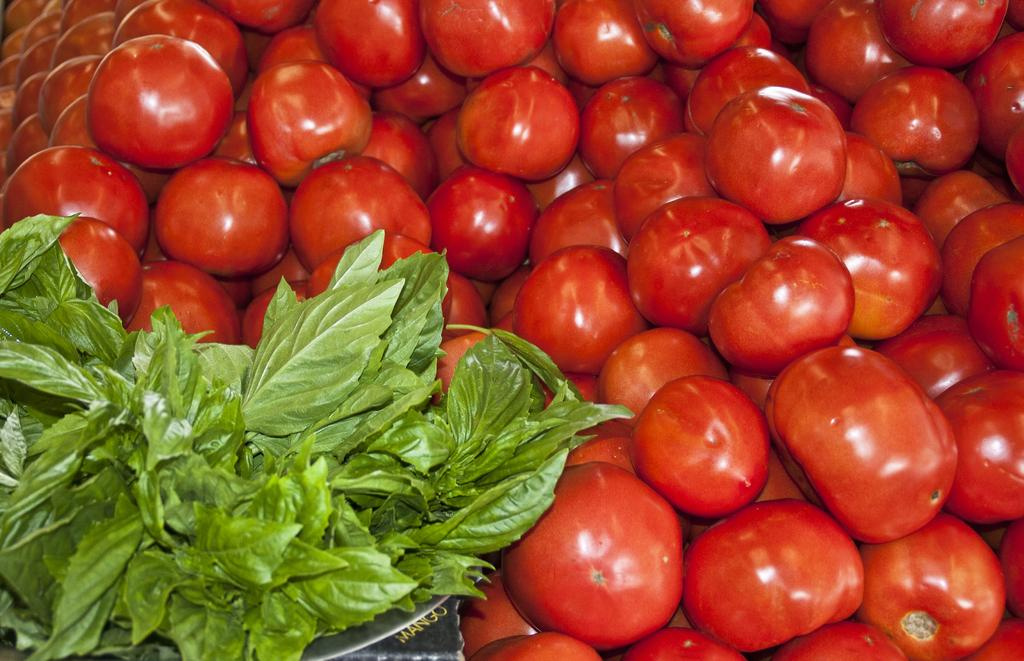What type of fruit is present in the image? There are tomatoes in the image. What color are the tomatoes? The tomatoes are red in color. What other type of plant is visible in the image? There are green leaves in the image. What is the color of the object with the written word? The object with the written word is black. How does the grip of the tomatoes change over time in the image? The image does not show any change in the grip of the tomatoes, as they are stationary and not being held or manipulated. 